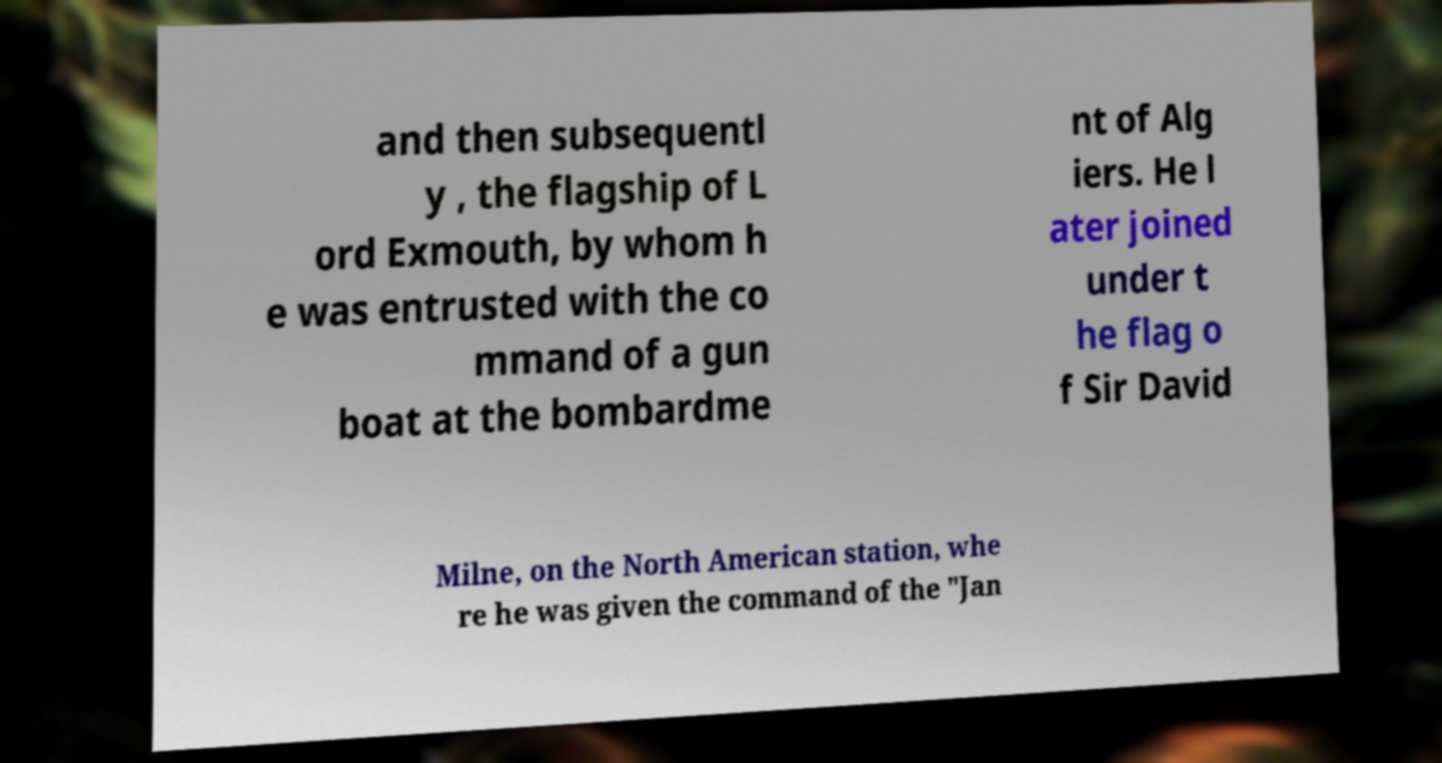There's text embedded in this image that I need extracted. Can you transcribe it verbatim? and then subsequentl y , the flagship of L ord Exmouth, by whom h e was entrusted with the co mmand of a gun boat at the bombardme nt of Alg iers. He l ater joined under t he flag o f Sir David Milne, on the North American station, whe re he was given the command of the "Jan 